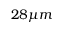Convert formula to latex. <formula><loc_0><loc_0><loc_500><loc_500>2 8 \mu m</formula> 